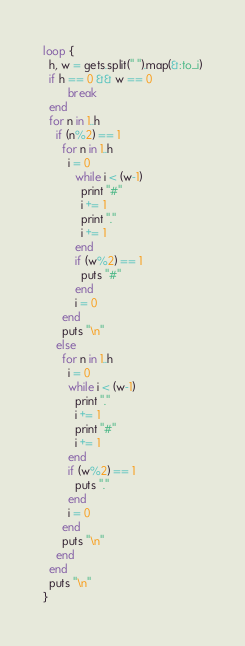<code> <loc_0><loc_0><loc_500><loc_500><_Ruby_>loop {
  h, w = gets.split(" ").map(&:to_i)
  if h == 0 && w == 0
        break
  end
  for n in 1..h
    if (n%2) == 1
      for n in 1..h
        i = 0
          while i < (w-1)
            print "#"
            i += 1
            print "."
            i += 1
          end
          if (w%2) == 1
            puts "#"
          end
          i = 0
      end
      puts "\n"
    else
      for n in 1..h
        i = 0
        while i < (w-1)
          print "."
          i += 1
          print "#"
          i += 1
        end
        if (w%2) == 1
          puts "."
        end
        i = 0
      end
      puts "\n"
    end
  end
  puts "\n"
}</code> 